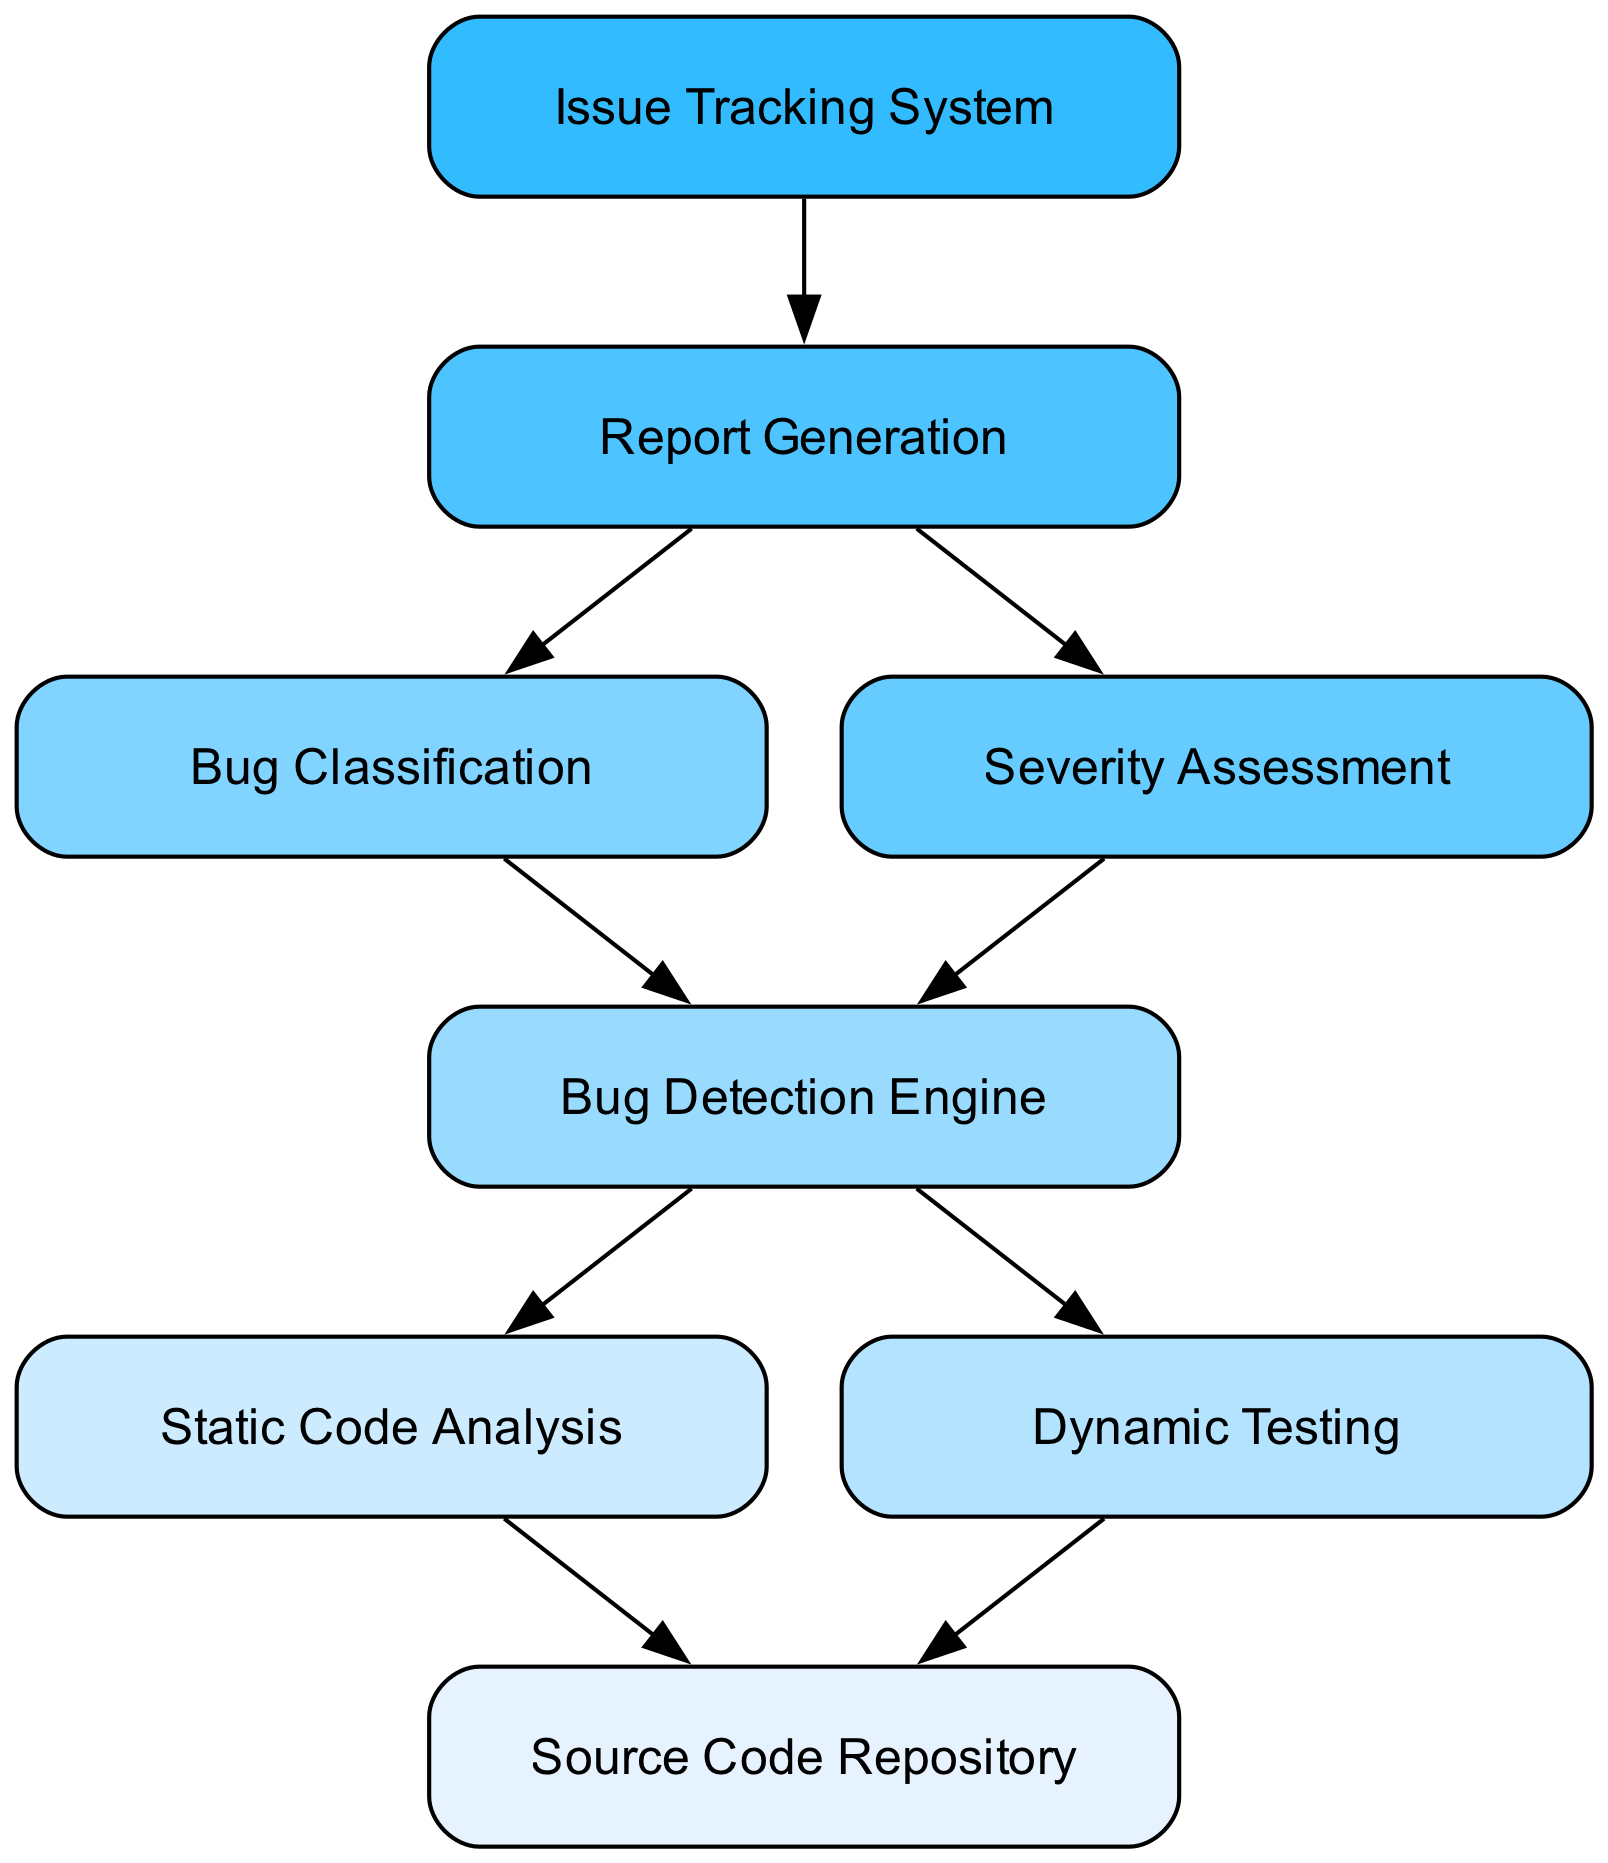What is the starting point of the process? The starting point of the process is the "Source Code Repository", which initiates the flow by providing the source code for analysis and testing.
Answer: Source Code Repository How many nodes are present in the diagram? Counting all the unique elements in the diagram, we find there are a total of eight nodes, from the "Source Code Repository" down to the "Issue Tracking System."
Answer: 8 What is the final output of the bug detection process? The final output of the process, as represented in the diagram, is the "Issue Tracking System", which receives reports on detected bugs.
Answer: Issue Tracking System Which processes feed into the Bug Detection Engine? The "Static Code Analysis" and "Dynamic Testing" processes both feed into the "Bug Detection Engine", providing their respective outputs for bug detection.
Answer: Static Code Analysis, Dynamic Testing What comes after Bug Classification in the workflow? The "Severity Assessment" comes after "Bug Classification," indicating that once bugs are classified, their severity is assessed.
Answer: Severity Assessment How many connections are directed towards Report Generation? There are two connections directed towards "Report Generation," one from "Bug Classification" and another from "Severity Assessment."
Answer: 2 What type of analysis does the system perform first? The system performs "Static Code Analysis" first, as it is one of the initial steps after fetching code from the "Source Code Repository."
Answer: Static Code Analysis Which node acts as a classifier for bugs? The "Bug Classification" node serves as the classifier for bugs, processing the output from the "Bug Detection Engine."
Answer: Bug Classification What is the purpose of the Bug Detection Engine? The purpose of the "Bug Detection Engine" is to analyze the input from both "Static Code Analysis" and "Dynamic Testing" to identify bugs in the code.
Answer: Analyze input for bug detection 